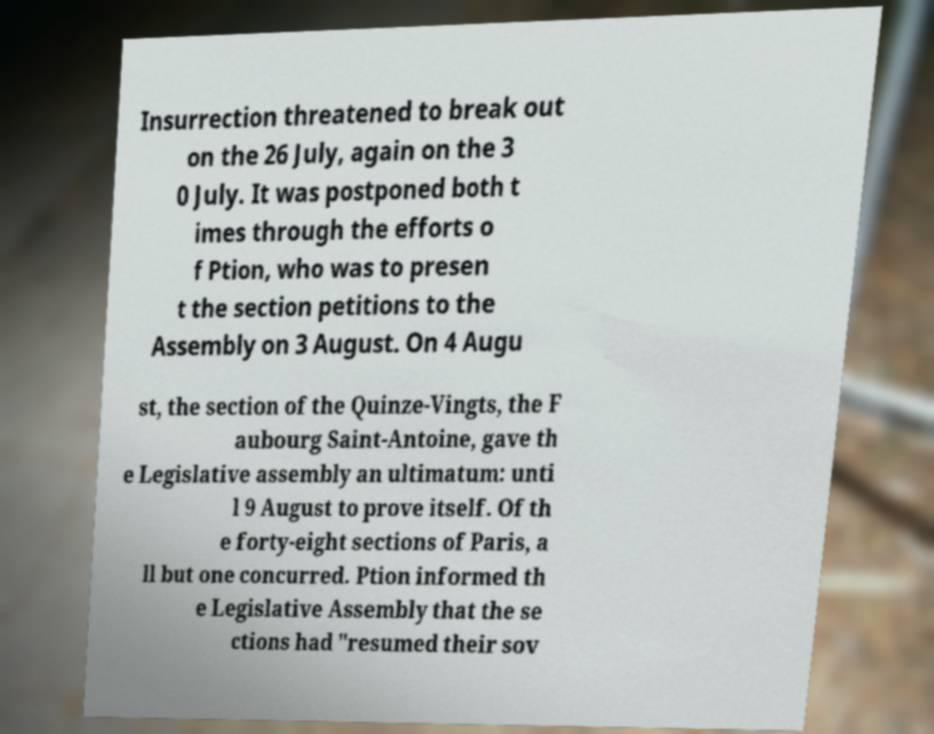Can you accurately transcribe the text from the provided image for me? Insurrection threatened to break out on the 26 July, again on the 3 0 July. It was postponed both t imes through the efforts o f Ption, who was to presen t the section petitions to the Assembly on 3 August. On 4 Augu st, the section of the Quinze-Vingts, the F aubourg Saint-Antoine, gave th e Legislative assembly an ultimatum: unti l 9 August to prove itself. Of th e forty-eight sections of Paris, a ll but one concurred. Ption informed th e Legislative Assembly that the se ctions had "resumed their sov 